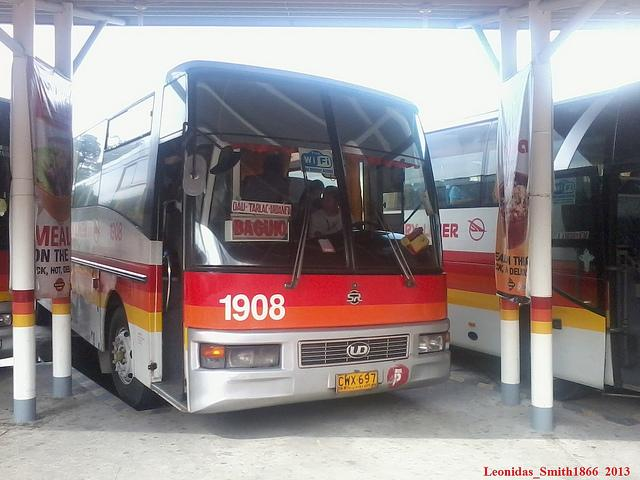What service is available when riding this bus? wifi 